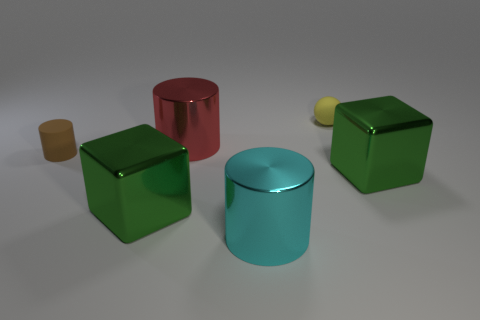There is a big cyan thing that is the same shape as the small brown matte object; what is it made of?
Make the answer very short. Metal. What color is the matte cylinder?
Offer a very short reply. Brown. There is a tiny matte ball behind the object that is right of the yellow object; what is its color?
Your answer should be compact. Yellow. There is a green block to the left of the small thing on the right side of the small brown rubber thing; how many green cubes are in front of it?
Your answer should be very brief. 0. There is a yellow rubber ball; are there any metal objects to the left of it?
Your answer should be compact. Yes. What number of cylinders are big things or big green objects?
Provide a short and direct response. 2. What number of things are on the right side of the big red shiny object and in front of the brown matte cylinder?
Ensure brevity in your answer.  2. Are there an equal number of brown matte things that are on the right side of the red shiny object and small matte balls that are on the right side of the ball?
Your answer should be very brief. Yes. There is a matte object that is in front of the tiny yellow rubber object; is it the same shape as the cyan thing?
Your response must be concise. Yes. What shape is the big thing behind the thing that is on the left side of the large green metallic block left of the red metallic cylinder?
Your response must be concise. Cylinder. 